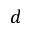Convert formula to latex. <formula><loc_0><loc_0><loc_500><loc_500>d</formula> 